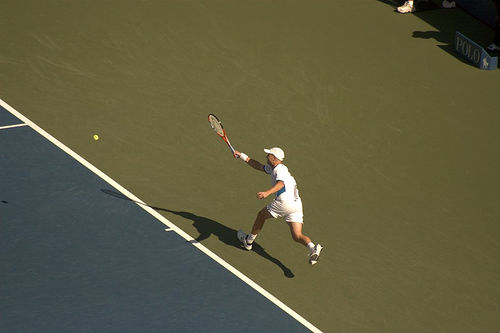Please transcribe the text in this image. POLO 